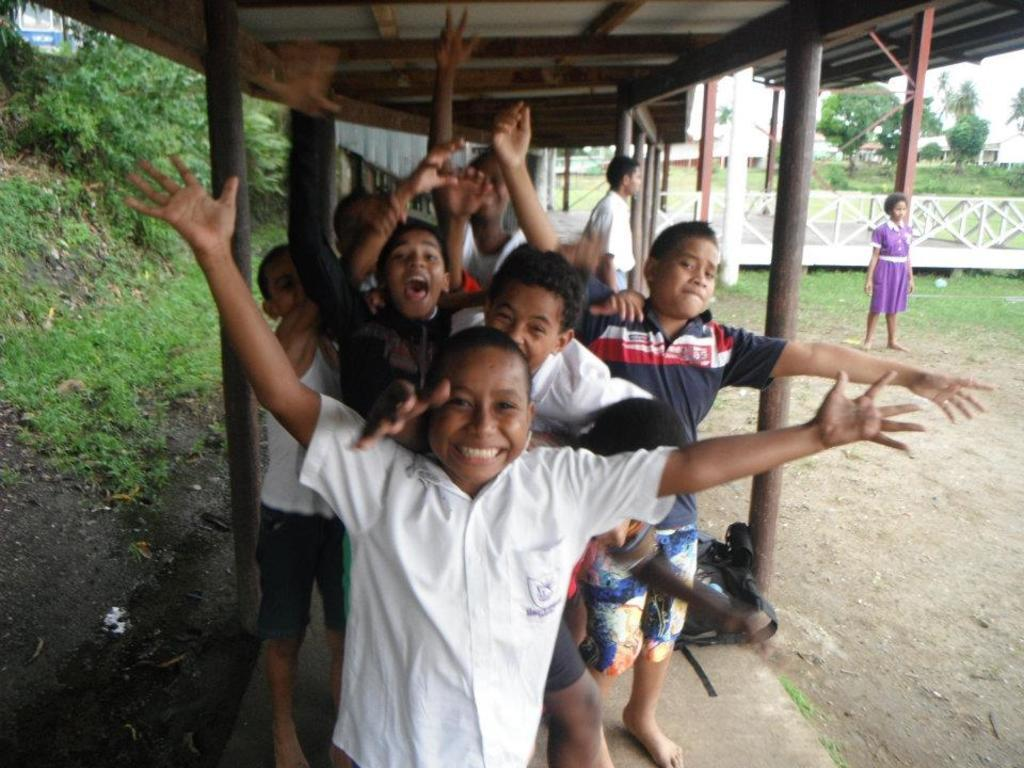How many people are in the image? There is a group of people in the image, but the exact number is not specified. What is the position of the people in the image? The people are standing on the ground in the image. What type of structure can be seen in the image? There is a shed in the image. What is the purpose of the fence in the image? The fence in the image serves as a boundary or barrier. What type of vegetation is present in the image? There are trees in the image. What type of current can be seen flowing through the kite in the image? There is no kite present in the image, so it is not possible to determine if there is any current flowing through it. 